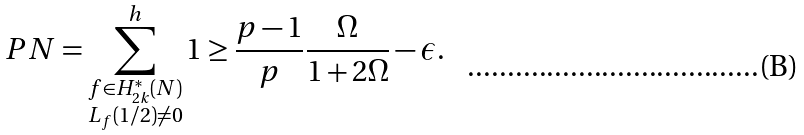Convert formula to latex. <formula><loc_0><loc_0><loc_500><loc_500>P N = \sum _ { \substack { f \in H _ { 2 k } ^ { * } ( N ) \\ L _ { f } ( 1 / 2 ) \neq 0 } } ^ { h } 1 \geq \frac { p - 1 } { p } \frac { \Omega } { 1 + 2 \Omega } - \epsilon .</formula> 